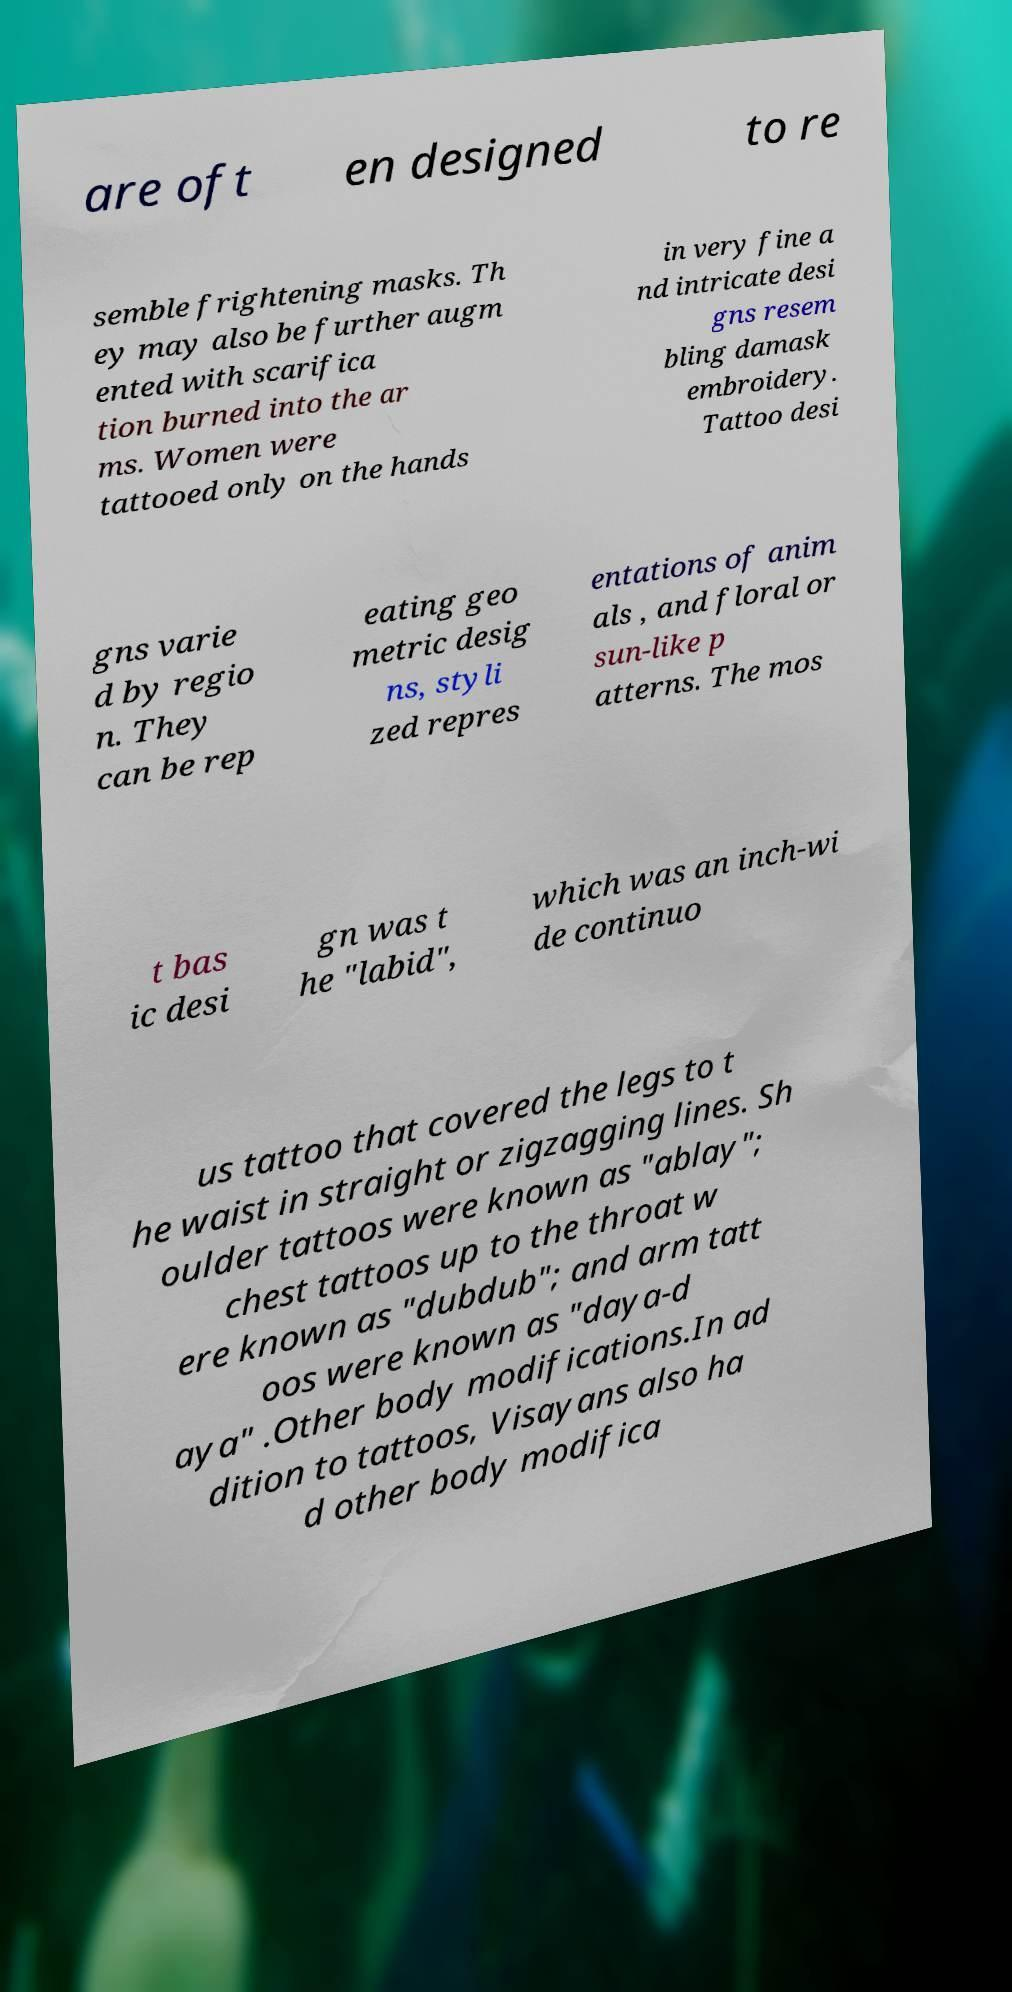Can you accurately transcribe the text from the provided image for me? are oft en designed to re semble frightening masks. Th ey may also be further augm ented with scarifica tion burned into the ar ms. Women were tattooed only on the hands in very fine a nd intricate desi gns resem bling damask embroidery. Tattoo desi gns varie d by regio n. They can be rep eating geo metric desig ns, styli zed repres entations of anim als , and floral or sun-like p atterns. The mos t bas ic desi gn was t he "labid", which was an inch-wi de continuo us tattoo that covered the legs to t he waist in straight or zigzagging lines. Sh oulder tattoos were known as "ablay"; chest tattoos up to the throat w ere known as "dubdub"; and arm tatt oos were known as "daya-d aya" .Other body modifications.In ad dition to tattoos, Visayans also ha d other body modifica 